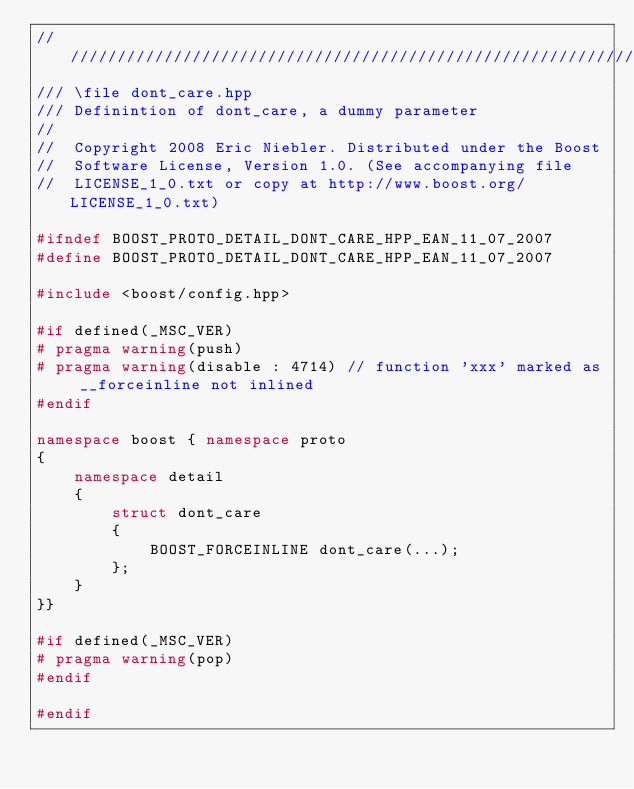<code> <loc_0><loc_0><loc_500><loc_500><_C++_>///////////////////////////////////////////////////////////////////////////////
/// \file dont_care.hpp
/// Definintion of dont_care, a dummy parameter
//
//  Copyright 2008 Eric Niebler. Distributed under the Boost
//  Software License, Version 1.0. (See accompanying file
//  LICENSE_1_0.txt or copy at http://www.boost.org/LICENSE_1_0.txt)

#ifndef BOOST_PROTO_DETAIL_DONT_CARE_HPP_EAN_11_07_2007
#define BOOST_PROTO_DETAIL_DONT_CARE_HPP_EAN_11_07_2007

#include <boost/config.hpp>

#if defined(_MSC_VER)
# pragma warning(push)
# pragma warning(disable : 4714) // function 'xxx' marked as __forceinline not inlined
#endif

namespace boost { namespace proto
{
    namespace detail
    {
        struct dont_care
        {
            BOOST_FORCEINLINE dont_care(...);
        };
    }
}}

#if defined(_MSC_VER)
# pragma warning(pop)
#endif

#endif
</code> 